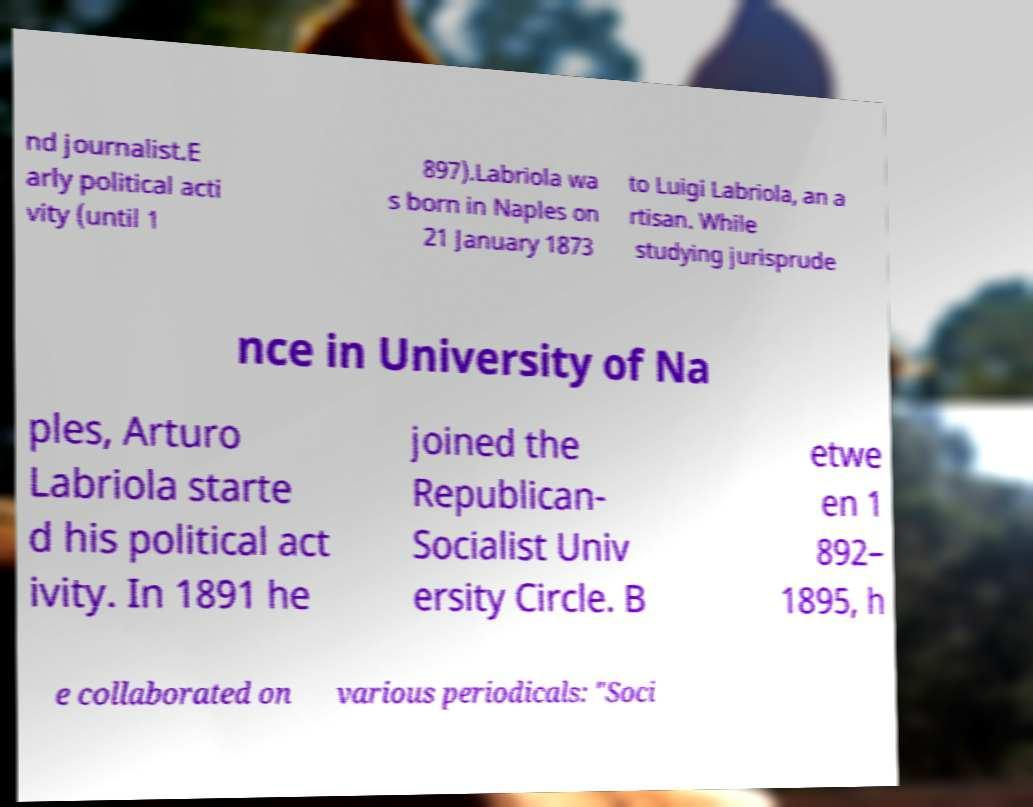Can you read and provide the text displayed in the image?This photo seems to have some interesting text. Can you extract and type it out for me? nd journalist.E arly political acti vity (until 1 897).Labriola wa s born in Naples on 21 January 1873 to Luigi Labriola, an a rtisan. While studying jurisprude nce in University of Na ples, Arturo Labriola starte d his political act ivity. In 1891 he joined the Republican- Socialist Univ ersity Circle. B etwe en 1 892– 1895, h e collaborated on various periodicals: "Soci 